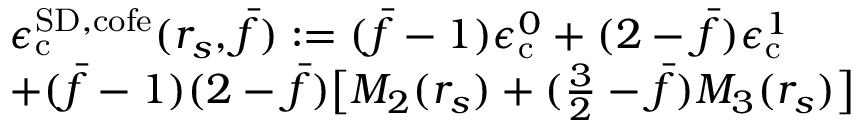Convert formula to latex. <formula><loc_0><loc_0><loc_500><loc_500>\begin{array} { r l } & { \epsilon _ { c } ^ { { S D } , c o f e } ( r _ { s } , \bar { f } ) \colon = ( \bar { f } - 1 ) \epsilon _ { c } ^ { 0 } + ( 2 - \bar { f } ) \epsilon _ { c } ^ { 1 } } \\ & { + ( \bar { f } - 1 ) ( 2 - \bar { f } ) \left [ M _ { 2 } ( r _ { s } ) + ( \frac { 3 } { 2 } - \bar { f } ) M _ { 3 } ( r _ { s } ) \right ] } \end{array}</formula> 